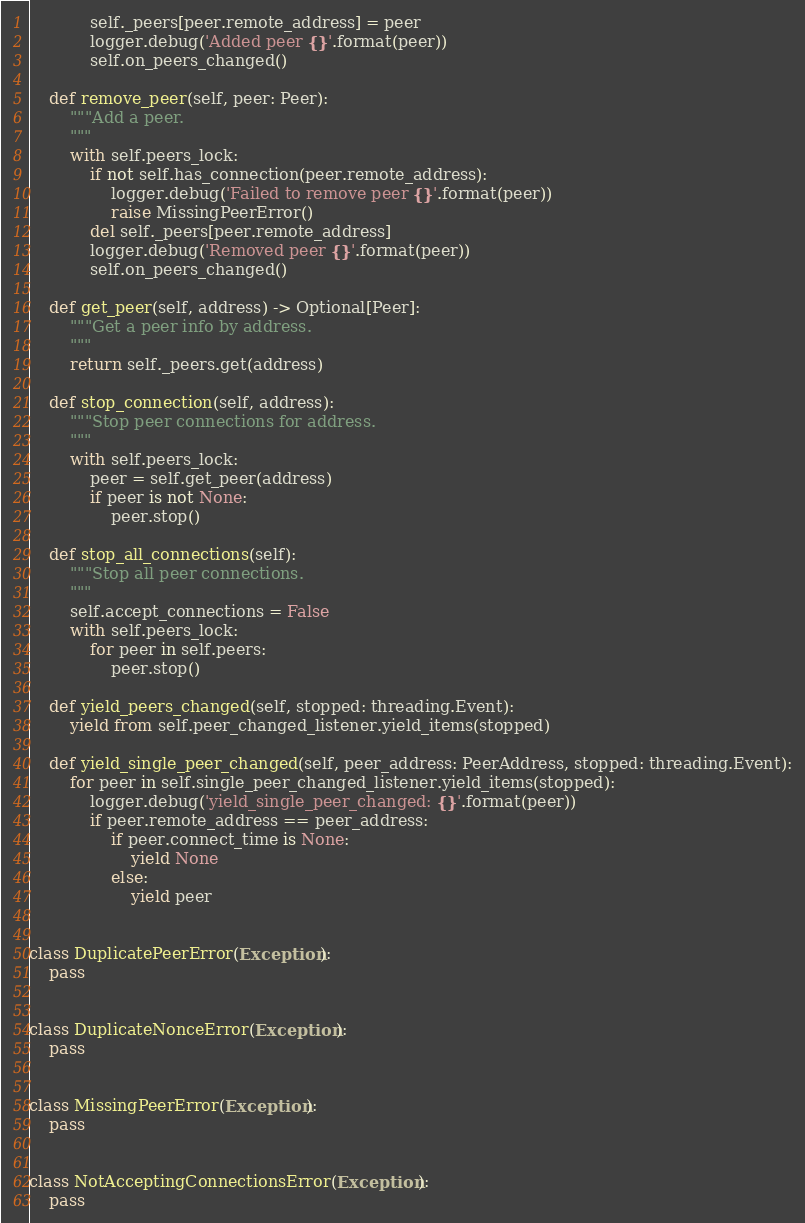<code> <loc_0><loc_0><loc_500><loc_500><_Python_>            self._peers[peer.remote_address] = peer
            logger.debug('Added peer {}'.format(peer))
            self.on_peers_changed()

    def remove_peer(self, peer: Peer):
        """Add a peer.
        """
        with self.peers_lock:
            if not self.has_connection(peer.remote_address):
                logger.debug('Failed to remove peer {}'.format(peer))
                raise MissingPeerError()
            del self._peers[peer.remote_address]
            logger.debug('Removed peer {}'.format(peer))
            self.on_peers_changed()

    def get_peer(self, address) -> Optional[Peer]:
        """Get a peer info by address.
        """
        return self._peers.get(address)

    def stop_connection(self, address):
        """Stop peer connections for address.
        """
        with self.peers_lock:
            peer = self.get_peer(address)
            if peer is not None:
                peer.stop()

    def stop_all_connections(self):
        """Stop all peer connections.
        """
        self.accept_connections = False
        with self.peers_lock:
            for peer in self.peers:
                peer.stop()

    def yield_peers_changed(self, stopped: threading.Event):
        yield from self.peer_changed_listener.yield_items(stopped)

    def yield_single_peer_changed(self, peer_address: PeerAddress, stopped: threading.Event):
        for peer in self.single_peer_changed_listener.yield_items(stopped):
            logger.debug('yield_single_peer_changed: {}'.format(peer))
            if peer.remote_address == peer_address:
                if peer.connect_time is None:
                    yield None
                else:
                    yield peer


class DuplicatePeerError(Exception):
    pass


class DuplicateNonceError(Exception):
    pass


class MissingPeerError(Exception):
    pass


class NotAcceptingConnectionsError(Exception):
    pass
</code> 